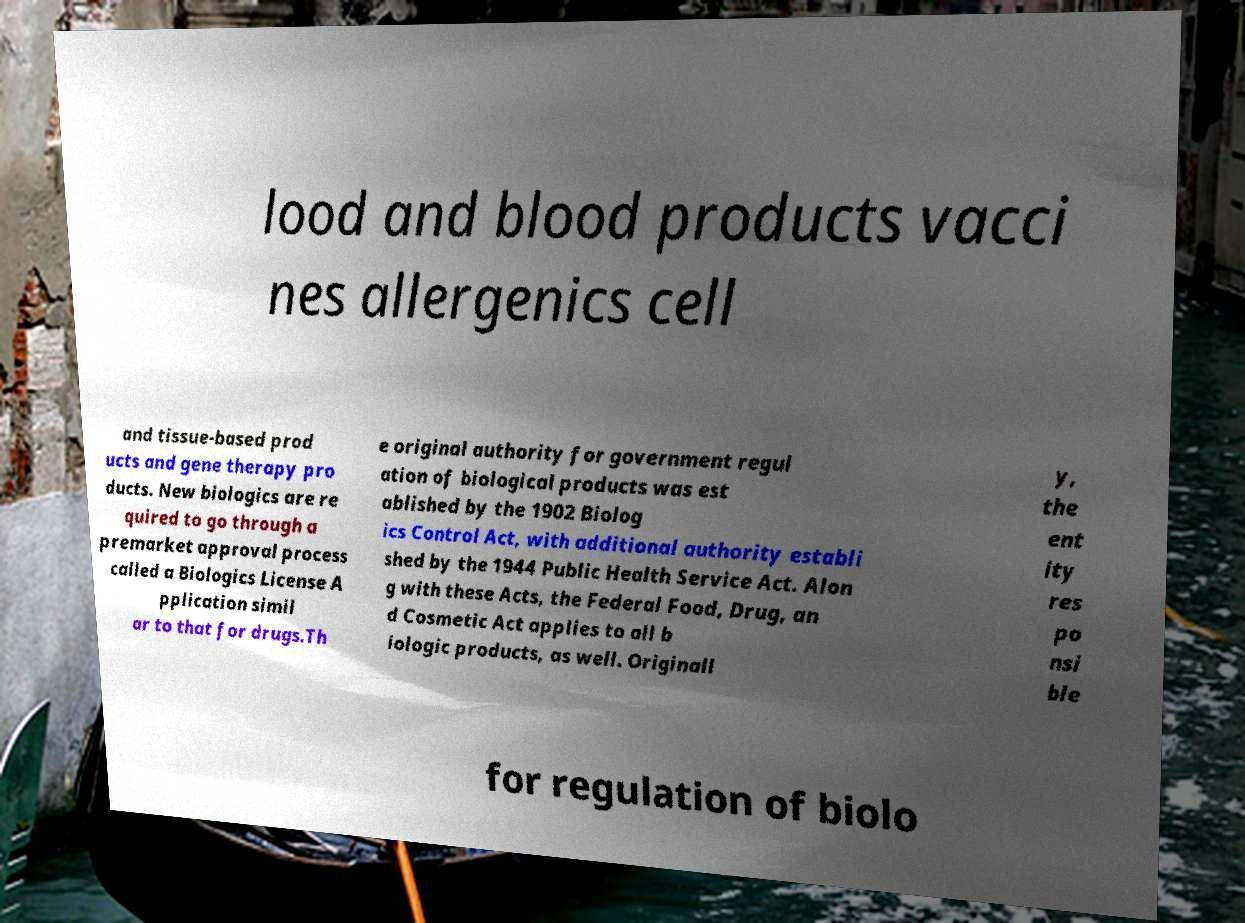Can you accurately transcribe the text from the provided image for me? lood and blood products vacci nes allergenics cell and tissue-based prod ucts and gene therapy pro ducts. New biologics are re quired to go through a premarket approval process called a Biologics License A pplication simil ar to that for drugs.Th e original authority for government regul ation of biological products was est ablished by the 1902 Biolog ics Control Act, with additional authority establi shed by the 1944 Public Health Service Act. Alon g with these Acts, the Federal Food, Drug, an d Cosmetic Act applies to all b iologic products, as well. Originall y, the ent ity res po nsi ble for regulation of biolo 